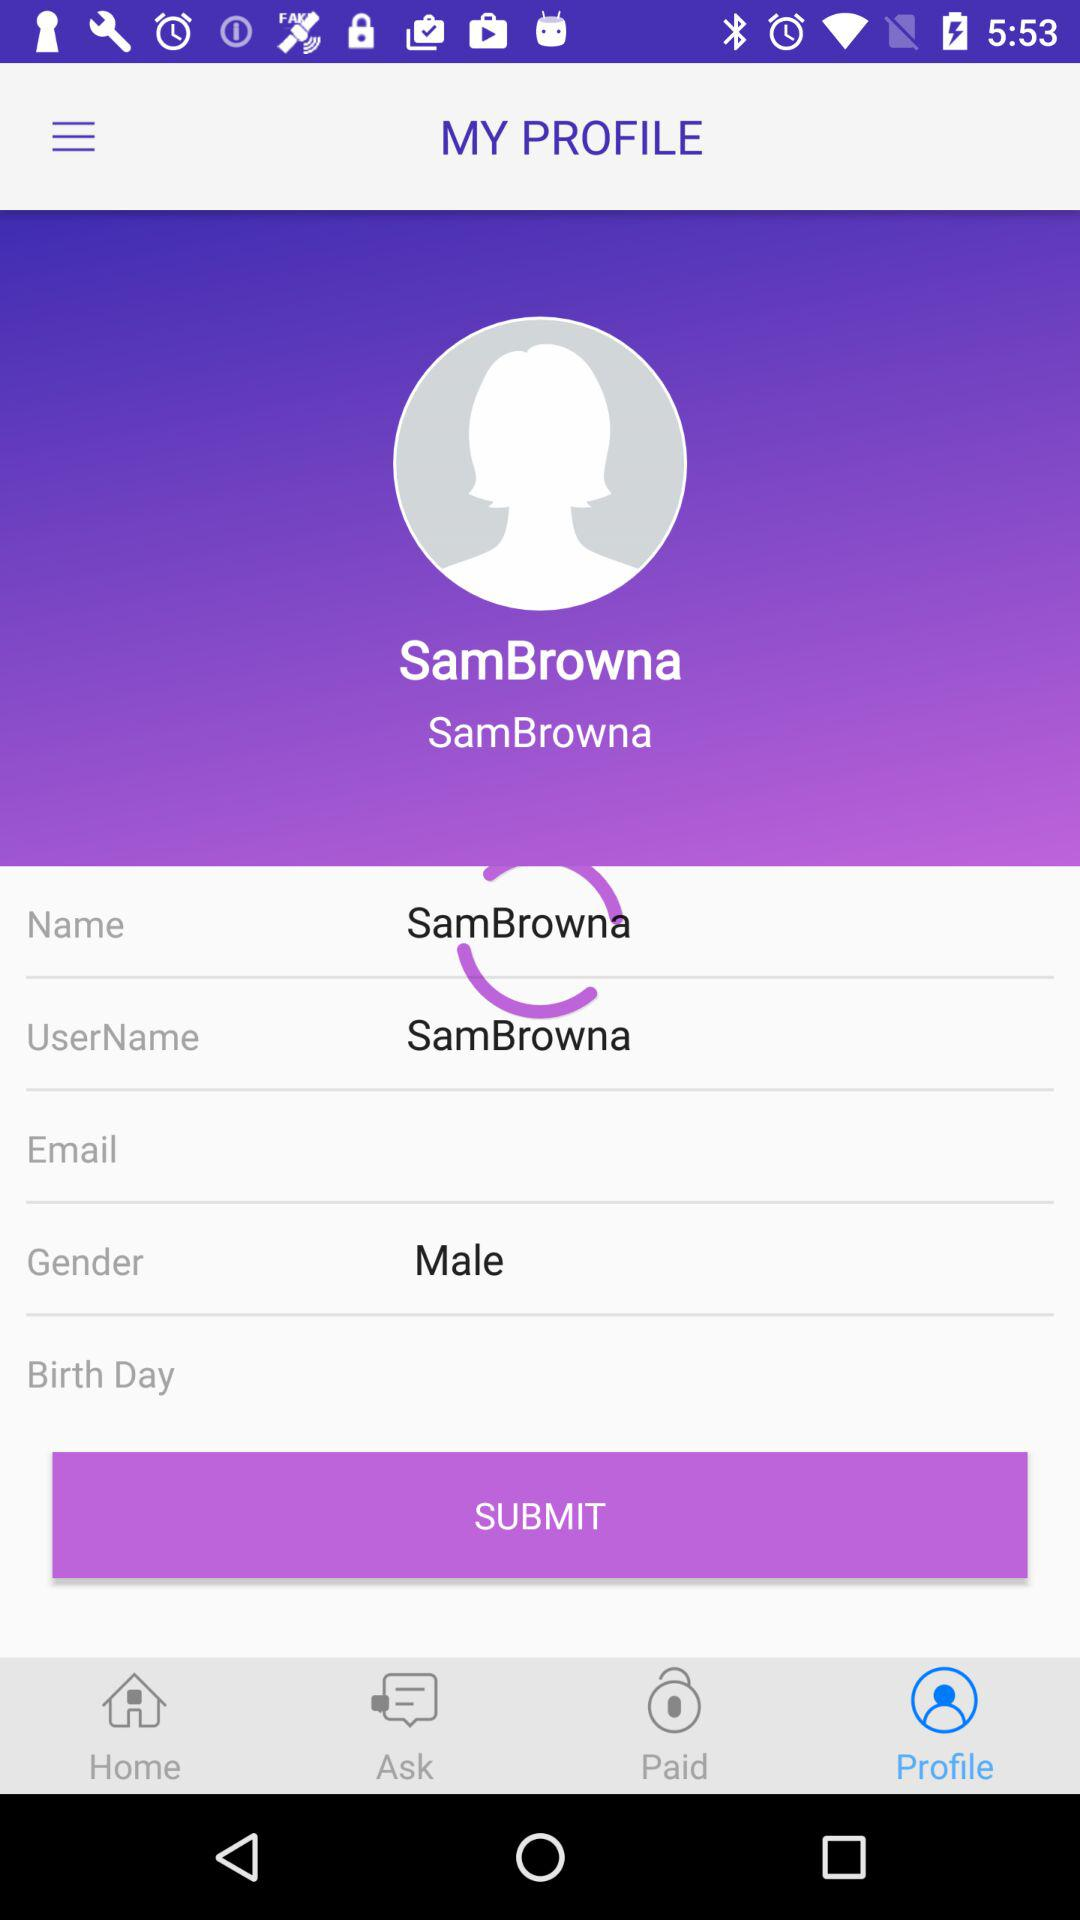When was the user born?
When the provided information is insufficient, respond with <no answer>. <no answer> 